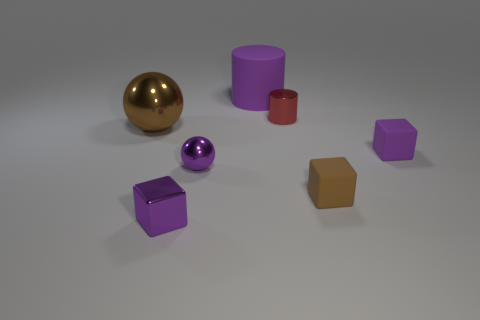What is the color of the matte thing that is right of the small brown thing? The matte object to the right of the small brown cube is a purple cube with a slightly reflective surface. 